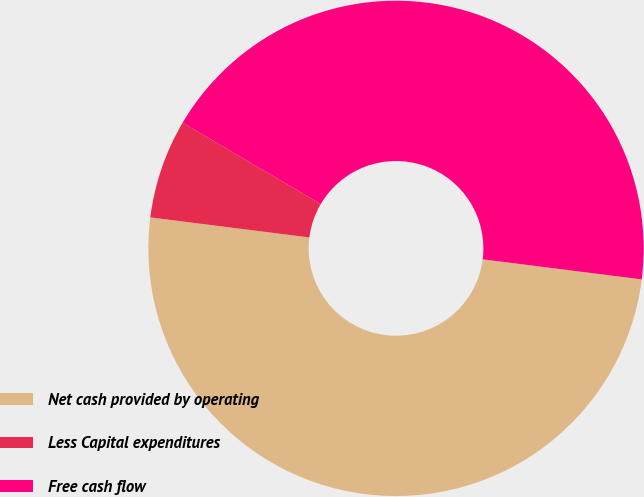Convert chart. <chart><loc_0><loc_0><loc_500><loc_500><pie_chart><fcel>Net cash provided by operating<fcel>Less Capital expenditures<fcel>Free cash flow<nl><fcel>50.0%<fcel>6.47%<fcel>43.53%<nl></chart> 